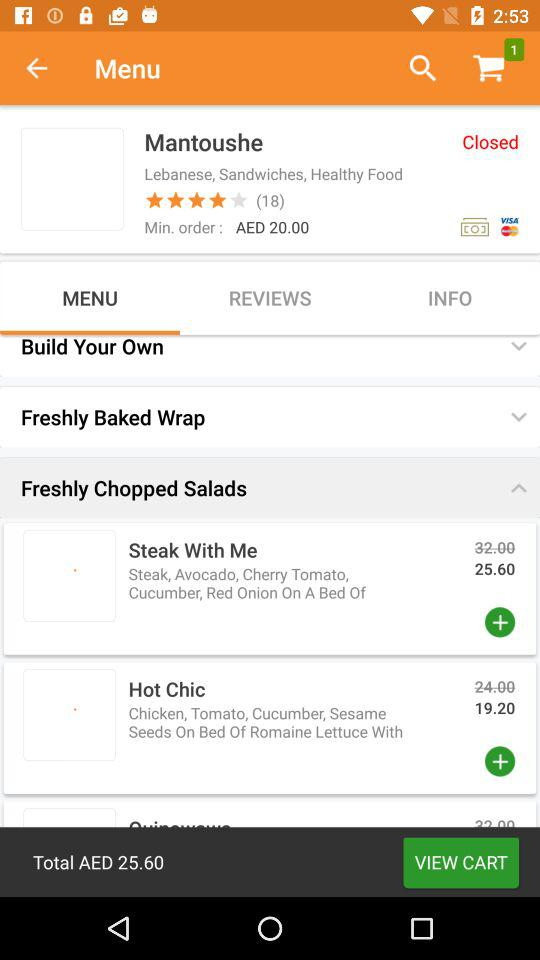What is the price of the hot chic? The price of the hot chic is 19.20. 